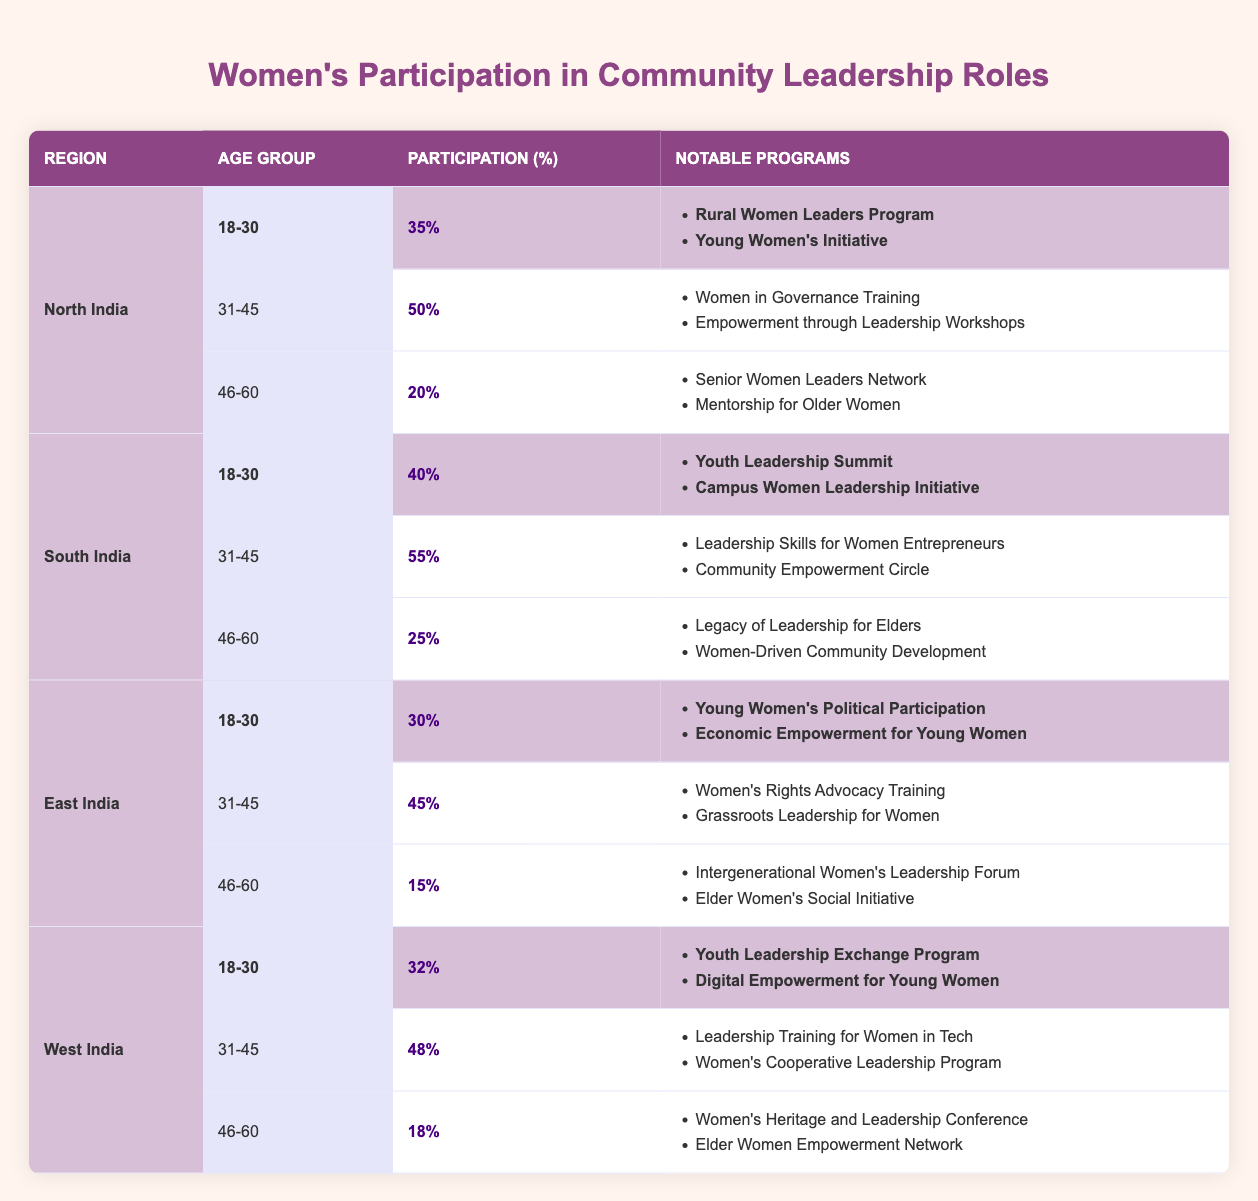What is the participation percentage of women aged 31-45 in South India? The table specifies the participation percentage for the age group 31-45 in South India, which is listed as 55%.
Answer: 55% Which region has the lowest participation percentage for women aged 46-60? By analyzing the table, East India shows the lowest participation percentage of 15% for women in the 46-60 age group.
Answer: East India What are the notable programs for women aged 18-30 in North India? The table specifies the notable programs for the 18-30 age group in North India, which are "Rural Women Leaders Program" and "Young Women's Initiative."
Answer: Rural Women Leaders Program, Young Women's Initiative What is the average participation percentage of women aged 46-60 across all regions? To find the average, sum the percentages: (20 + 25 + 15 + 18) = 78, then divide by 4: 78/4 = 19.5%.
Answer: 19.5% Is the participation percentage for women aged 18-30 higher in South India than in East India? South India has 40% participation for the 18-30 age group while East India has 30%, thus it is true that South India has a higher percentage.
Answer: Yes Which age group in West India shows the greatest participation percentage? The participation percentage for West India shows 48% for the age group 31-45, which is the highest among the listed age groups in that region.
Answer: 31-45 What is the difference in participation percentages between women aged 31-45 in North India and East India? North India has a participation percentage of 50%, while East India has 45%. The difference is calculated as 50 - 45 = 5%.
Answer: 5% Are there any regions where women aged 46-60 have a participation percentage greater than 20%? North India has 20%, South India has 25%, while East India and West India have lower percentages. Thus, South India is the only region above 20% for this age group.
Answer: Yes 